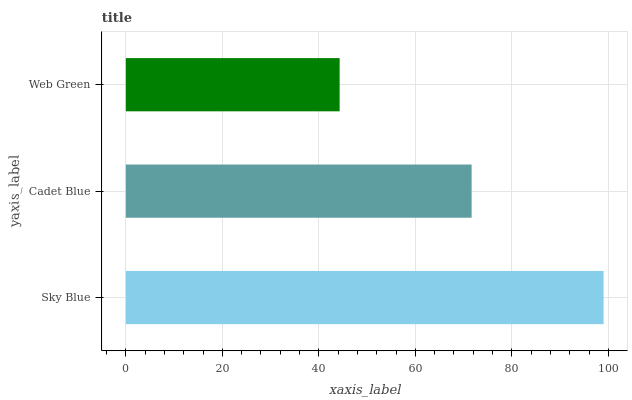Is Web Green the minimum?
Answer yes or no. Yes. Is Sky Blue the maximum?
Answer yes or no. Yes. Is Cadet Blue the minimum?
Answer yes or no. No. Is Cadet Blue the maximum?
Answer yes or no. No. Is Sky Blue greater than Cadet Blue?
Answer yes or no. Yes. Is Cadet Blue less than Sky Blue?
Answer yes or no. Yes. Is Cadet Blue greater than Sky Blue?
Answer yes or no. No. Is Sky Blue less than Cadet Blue?
Answer yes or no. No. Is Cadet Blue the high median?
Answer yes or no. Yes. Is Cadet Blue the low median?
Answer yes or no. Yes. Is Web Green the high median?
Answer yes or no. No. Is Web Green the low median?
Answer yes or no. No. 